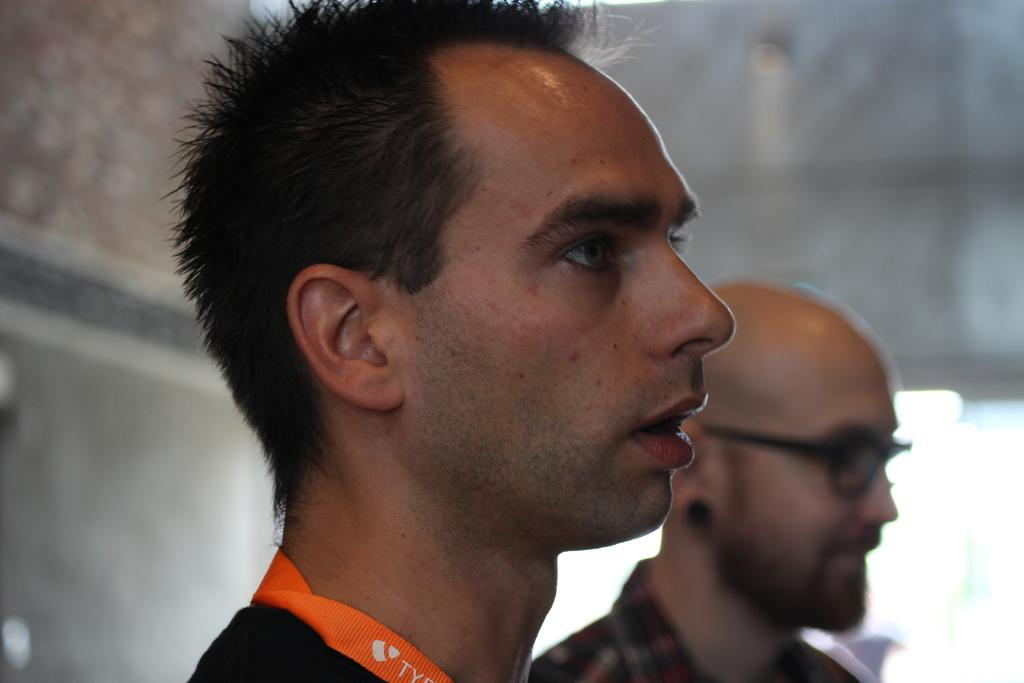How many people are in the image? The number of people in the image is not specified, but there are persons present. Can you describe the background of the image? The background of the image is blurry. What type of metal can be seen in the image? There is no mention of any metal in the image, so it cannot be determined from the provided facts. 